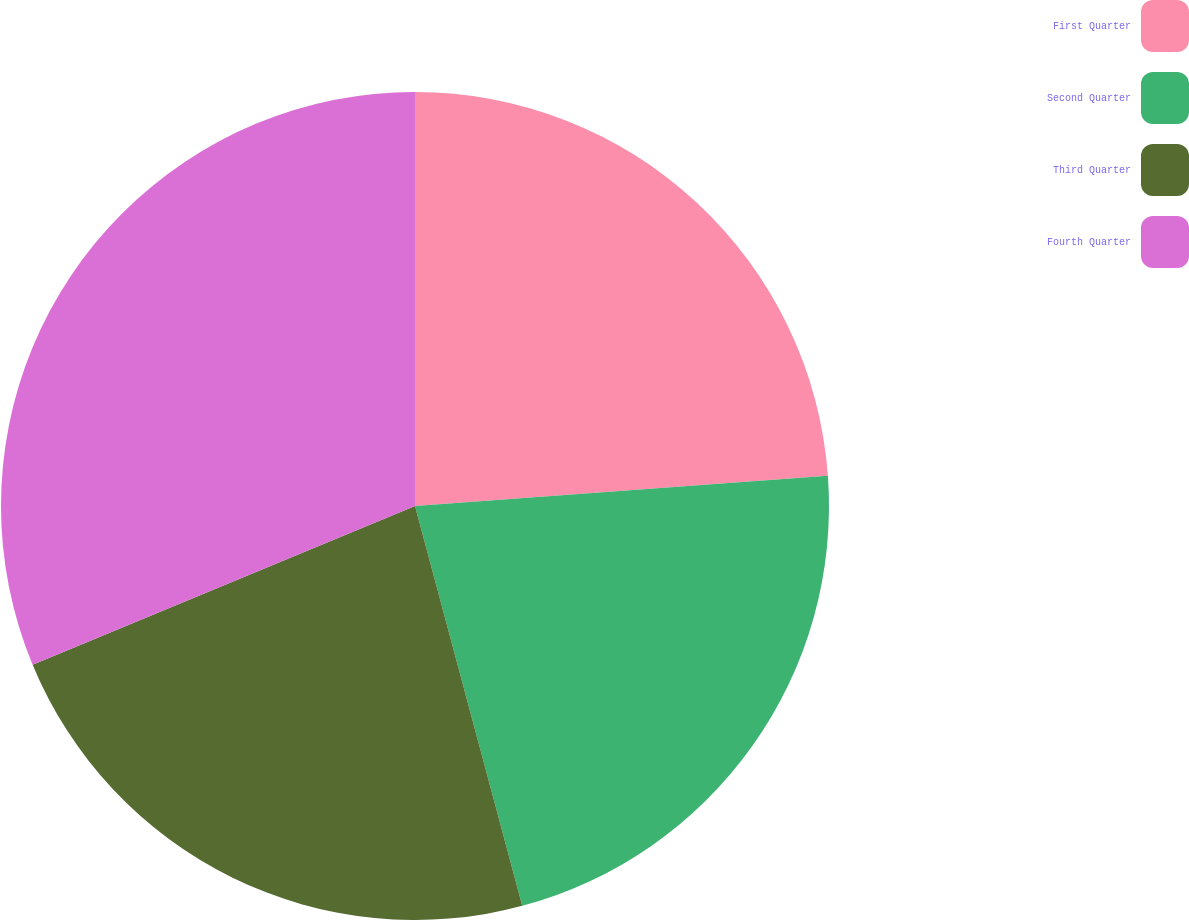<chart> <loc_0><loc_0><loc_500><loc_500><pie_chart><fcel>First Quarter<fcel>Second Quarter<fcel>Third Quarter<fcel>Fourth Quarter<nl><fcel>23.84%<fcel>21.99%<fcel>22.91%<fcel>31.26%<nl></chart> 